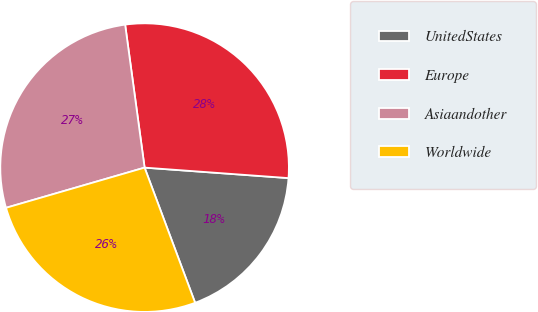<chart> <loc_0><loc_0><loc_500><loc_500><pie_chart><fcel>UnitedStates<fcel>Europe<fcel>Asiaandother<fcel>Worldwide<nl><fcel>18.15%<fcel>28.31%<fcel>27.34%<fcel>26.2%<nl></chart> 